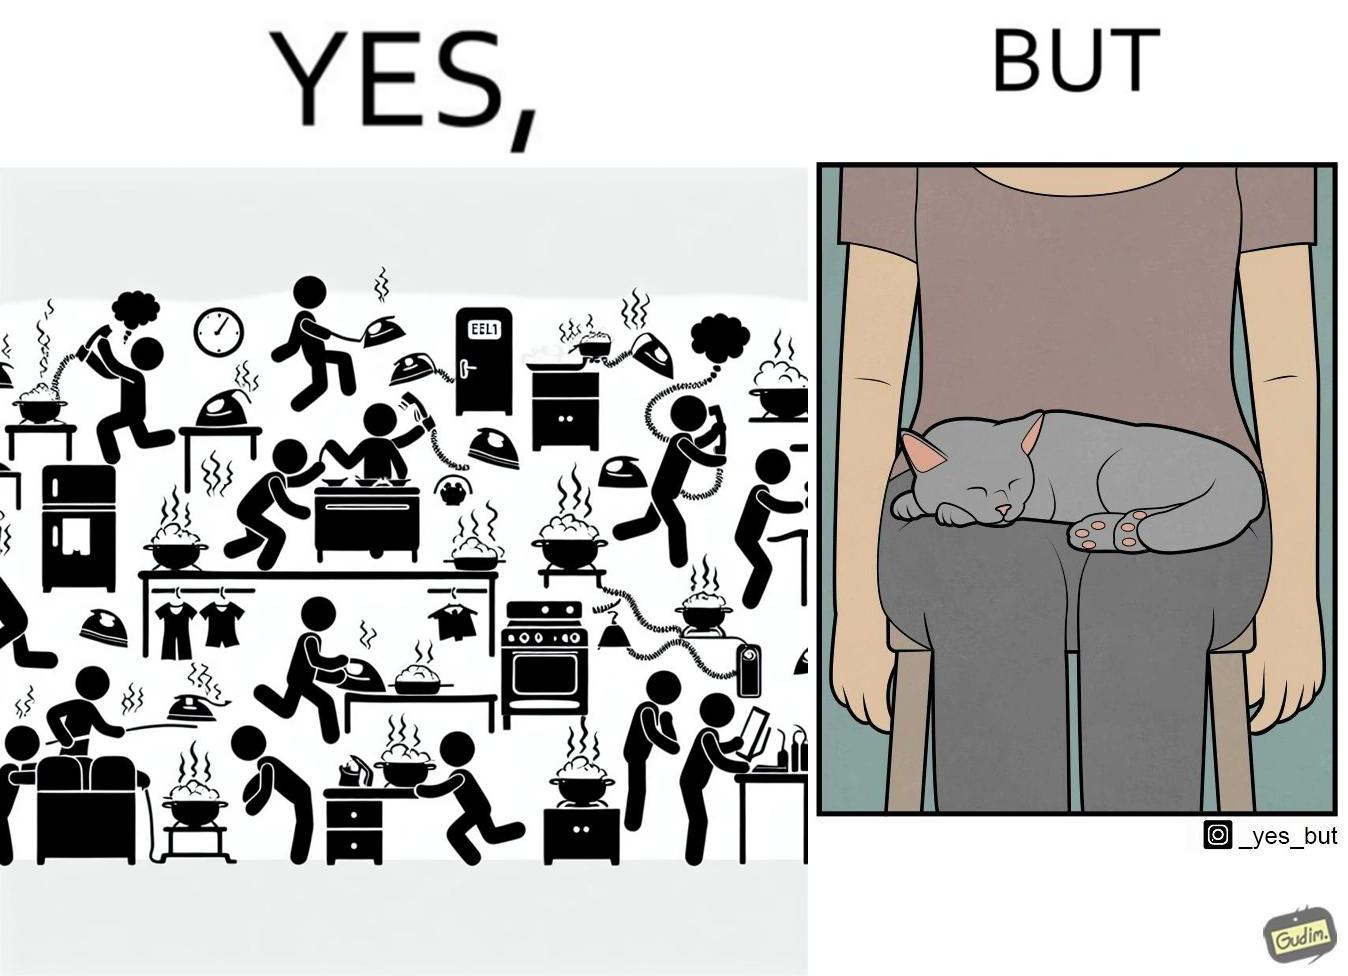Describe what you see in this image. the irony in this image is that people ignore all the chaos around them and get distracted by a cat. 